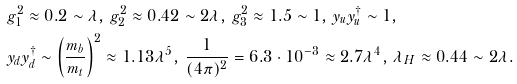<formula> <loc_0><loc_0><loc_500><loc_500>& g _ { 1 } ^ { 2 } \approx 0 . 2 \sim \lambda , \, g _ { 2 } ^ { 2 } \approx 0 . 4 2 \sim 2 \lambda , \, g _ { 3 } ^ { 2 } \approx 1 . 5 \sim 1 , \, y _ { u } y _ { u } ^ { \dagger } \sim 1 , \\ & y _ { d } y _ { d } ^ { \dagger } \sim \left ( \frac { m _ { b } } { m _ { t } } \right ) ^ { 2 } \approx 1 . 1 3 \lambda ^ { 5 } , \, \frac { 1 } { ( 4 \pi ) ^ { 2 } } = 6 . 3 \cdot 1 0 ^ { - 3 } \approx 2 . 7 \lambda ^ { 4 } , \, \lambda _ { H } \approx 0 . 4 4 \sim 2 \lambda . \\</formula> 